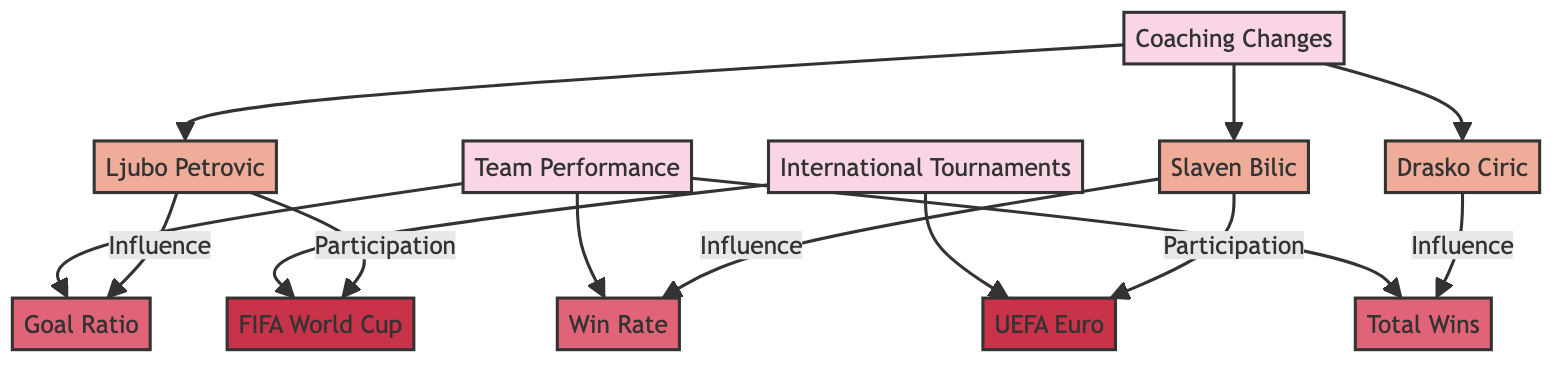What is the main focus of the directed graph? The directed graph focuses on the relationship between coaching changes and their impact on the Serbian national team's performance, displaying the influence of specific coaches on various performance metrics and tournament participation.
Answer: Coaching Changes and Their Impact on Serbian National Team Performance How many coaches are represented in the diagram? The diagram contains three coaches: Ljubo Petrovic, Slaven Bilic, and Drasko Ciric. This can be determined by counting the nodes connected to the "Coaching Changes" root node.
Answer: 3 Which coach is linked to the "Goal Ratio"? Ljubo Petrovic is the coach linked to the "Goal Ratio", as indicated by the directed edge stemming from his node towards the performance metric node.
Answer: Ljubo Petrovic What is the performance metric associated with Slaven Bilic? The performance metric associated with Slaven Bilic is the "Win Rate", as shown by the edge that connects his node to that specific performance metric node.
Answer: Win Rate Which tournament is Ljubo Petrovic connected to? Ljubo Petrovic is connected to the "FIFA World Cup", evidenced by the edge leading from his node to the associated tournament node in the diagram.
Answer: FIFA World Cup How does Drasko Ciric influence team performance? Drasko Ciric influences team performance through the "Total Wins", as indicated by the directed edge connecting his node to this performance metric node.
Answer: Total Wins Which performance metric is not influenced by any coach? The directed graph does not indicate any coach influencing multiple performance metrics. However, the "Goal Ratio", "Win Rate", and "Total Wins" metrics are all directly influenced by a coach or coaches, implying that none are left without influence.
Answer: None What relationships exist between coaching changes and international tournaments? The relationships show that Ljubo Petrovic participated in the "FIFA World Cup" and Slaven Bilic participated in the "UEFA Euro". These relationships indicate the direct participation of coaches in international tournaments based on the edges leading from their nodes to the tournament nodes.
Answer: Ljubo Petrovic - FIFA World Cup, Slaven Bilic - UEFA Euro How many performance metrics are in the diagram? There are three performance metrics depicted in the diagram: "Goal Ratio", "Win Rate", and "Total Wins". This can be counted from the edges connected to the "Team Performance" node.
Answer: 3 